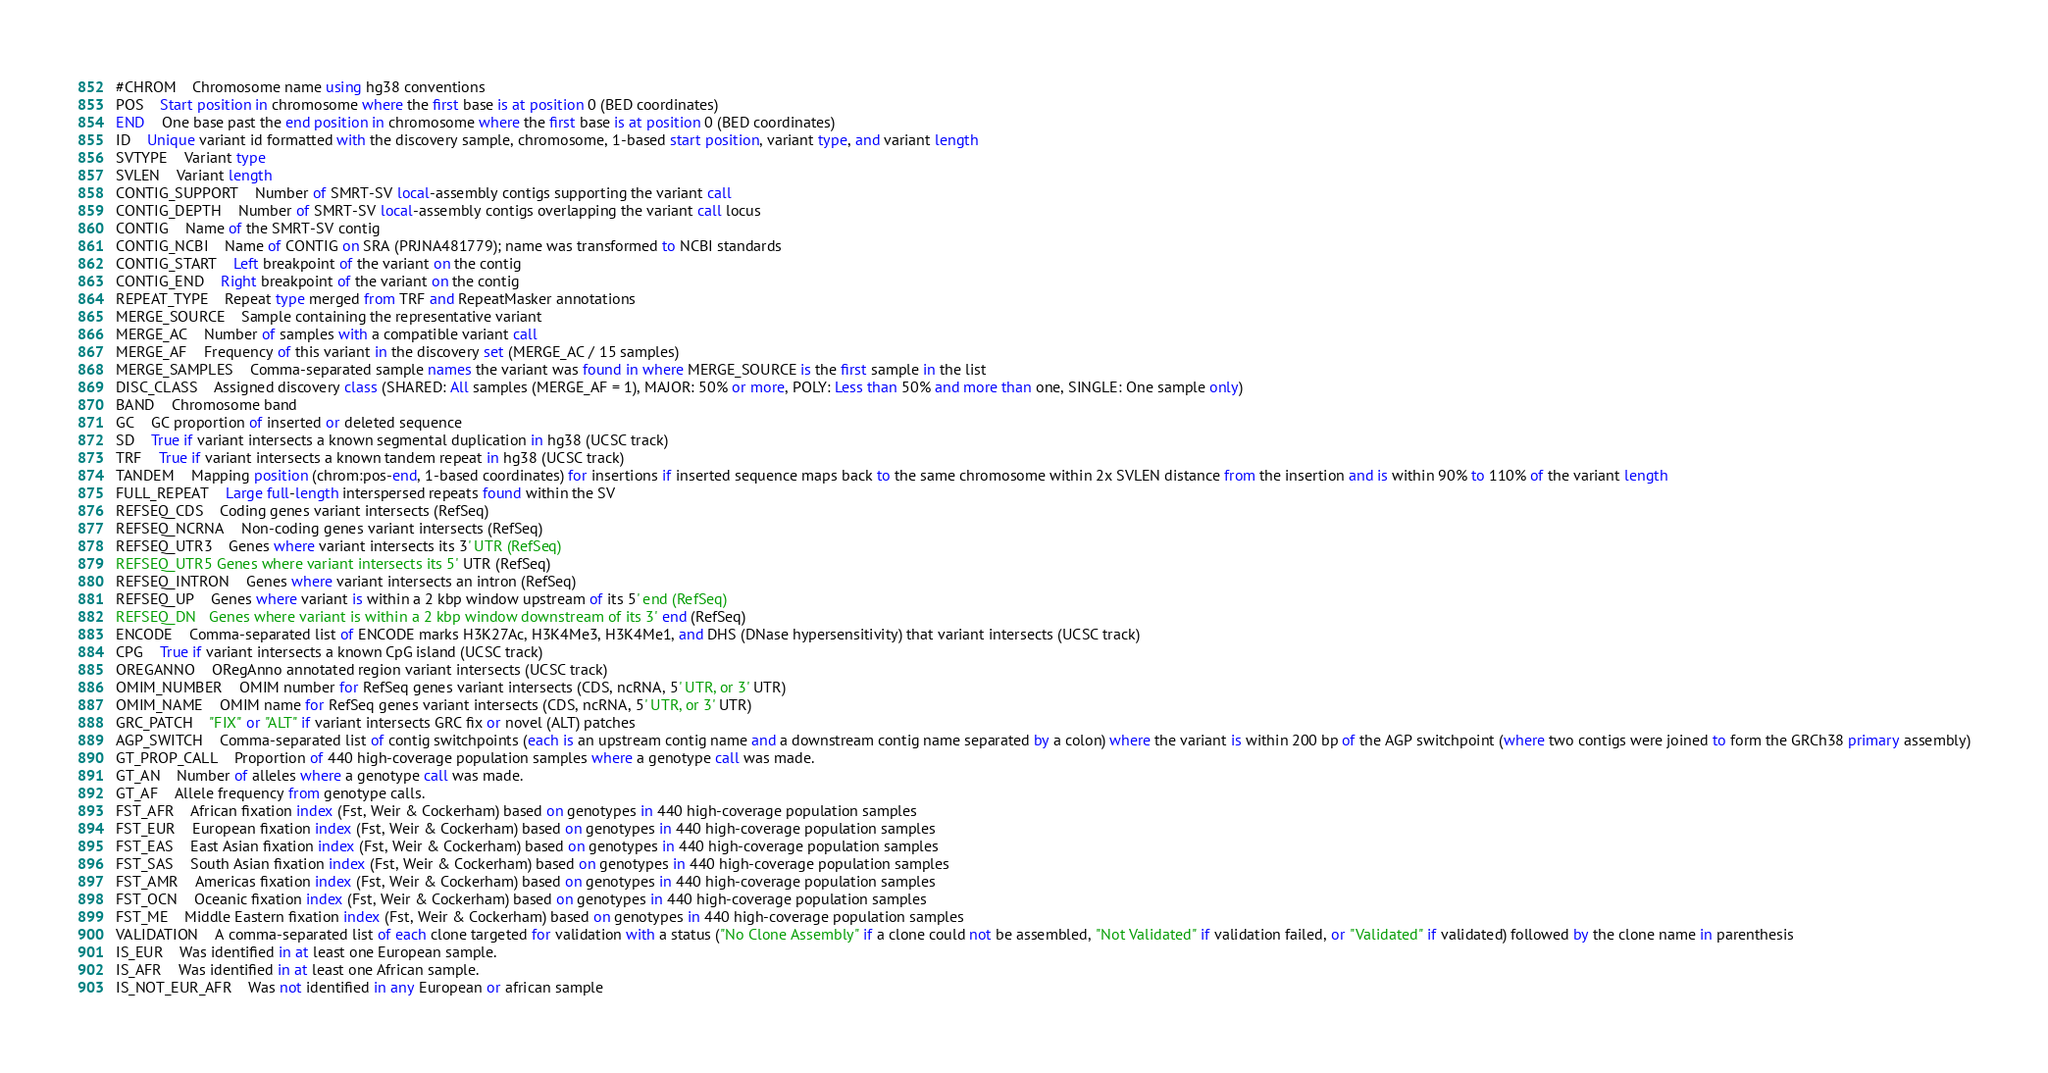Convert code to text. <code><loc_0><loc_0><loc_500><loc_500><_SQL_>#CHROM	Chromosome name using hg38 conventions
POS	Start position in chromosome where the first base is at position 0 (BED coordinates)
END	One base past the end position in chromosome where the first base is at position 0 (BED coordinates)
ID	Unique variant id formatted with the discovery sample, chromosome, 1-based start position, variant type, and variant length
SVTYPE	Variant type
SVLEN	Variant length
CONTIG_SUPPORT	Number of SMRT-SV local-assembly contigs supporting the variant call
CONTIG_DEPTH	Number of SMRT-SV local-assembly contigs overlapping the variant call locus
CONTIG	Name of the SMRT-SV contig
CONTIG_NCBI	Name of CONTIG on SRA (PRJNA481779); name was transformed to NCBI standards
CONTIG_START	Left breakpoint of the variant on the contig
CONTIG_END	Right breakpoint of the variant on the contig
REPEAT_TYPE	Repeat type merged from TRF and RepeatMasker annotations
MERGE_SOURCE	Sample containing the representative variant
MERGE_AC	Number of samples with a compatible variant call
MERGE_AF	Frequency of this variant in the discovery set (MERGE_AC / 15 samples)
MERGE_SAMPLES	Comma-separated sample names the variant was found in where MERGE_SOURCE is the first sample in the list
DISC_CLASS	Assigned discovery class (SHARED: All samples (MERGE_AF = 1), MAJOR: 50% or more, POLY: Less than 50% and more than one, SINGLE: One sample only)
BAND	Chromosome band
GC	GC proportion of inserted or deleted sequence
SD	True if variant intersects a known segmental duplication in hg38 (UCSC track)
TRF	True if variant intersects a known tandem repeat in hg38 (UCSC track)
TANDEM	Mapping position (chrom:pos-end, 1-based coordinates) for insertions if inserted sequence maps back to the same chromosome within 2x SVLEN distance from the insertion and is within 90% to 110% of the variant length
FULL_REPEAT	Large full-length interspersed repeats found within the SV
REFSEQ_CDS	Coding genes variant intersects (RefSeq)
REFSEQ_NCRNA	Non-coding genes variant intersects (RefSeq)
REFSEQ_UTR3	Genes where variant intersects its 3' UTR (RefSeq)
REFSEQ_UTR5	Genes where variant intersects its 5' UTR (RefSeq)
REFSEQ_INTRON	Genes where variant intersects an intron (RefSeq)
REFSEQ_UP	Genes where variant is within a 2 kbp window upstream of its 5' end (RefSeq)
REFSEQ_DN	Genes where variant is within a 2 kbp window downstream of its 3' end (RefSeq)
ENCODE	Comma-separated list of ENCODE marks H3K27Ac, H3K4Me3, H3K4Me1, and DHS (DNase hypersensitivity) that variant intersects (UCSC track)
CPG	True if variant intersects a known CpG island (UCSC track)
OREGANNO	ORegAnno annotated region variant intersects (UCSC track)
OMIM_NUMBER	OMIM number for RefSeq genes variant intersects (CDS, ncRNA, 5' UTR, or 3' UTR)
OMIM_NAME	OMIM name for RefSeq genes variant intersects (CDS, ncRNA, 5' UTR, or 3' UTR)
GRC_PATCH	"FIX" or "ALT" if variant intersects GRC fix or novel (ALT) patches
AGP_SWITCH	Comma-separated list of contig switchpoints (each is an upstream contig name and a downstream contig name separated by a colon) where the variant is within 200 bp of the AGP switchpoint (where two contigs were joined to form the GRCh38 primary assembly)
GT_PROP_CALL	Proportion of 440 high-coverage population samples where a genotype call was made.
GT_AN	Number of alleles where a genotype call was made.
GT_AF	Allele frequency from genotype calls.
FST_AFR	African fixation index (Fst, Weir & Cockerham) based on genotypes in 440 high-coverage population samples
FST_EUR	European fixation index (Fst, Weir & Cockerham) based on genotypes in 440 high-coverage population samples
FST_EAS	East Asian fixation index (Fst, Weir & Cockerham) based on genotypes in 440 high-coverage population samples
FST_SAS	South Asian fixation index (Fst, Weir & Cockerham) based on genotypes in 440 high-coverage population samples
FST_AMR	Americas fixation index (Fst, Weir & Cockerham) based on genotypes in 440 high-coverage population samples
FST_OCN	Oceanic fixation index (Fst, Weir & Cockerham) based on genotypes in 440 high-coverage population samples
FST_ME	Middle Eastern fixation index (Fst, Weir & Cockerham) based on genotypes in 440 high-coverage population samples
VALIDATION	A comma-separated list of each clone targeted for validation with a status ("No Clone Assembly" if a clone could not be assembled, "Not Validated" if validation failed, or "Validated" if validated) followed by the clone name in parenthesis
IS_EUR	Was identified in at least one European sample.
IS_AFR	Was identified in at least one African sample.
IS_NOT_EUR_AFR	Was not identified in any European or african sample
</code> 